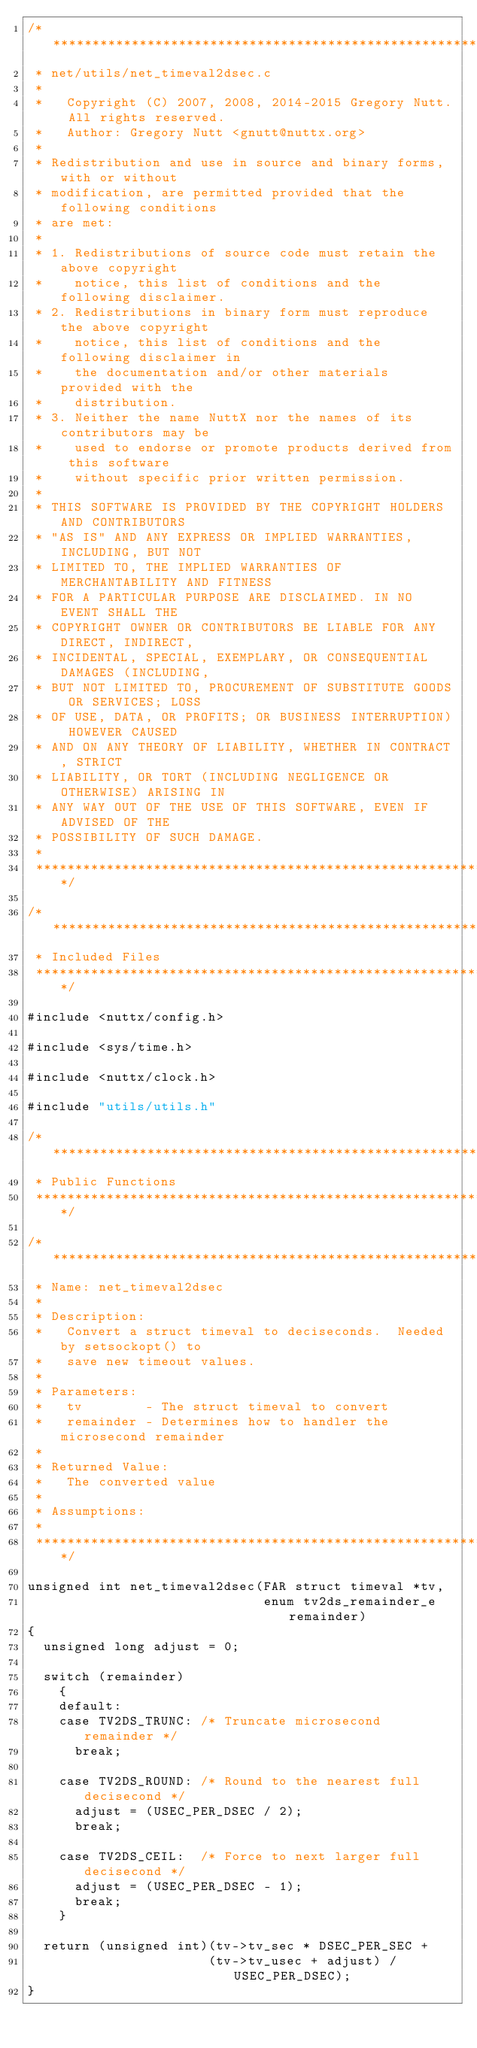<code> <loc_0><loc_0><loc_500><loc_500><_C_>/****************************************************************************
 * net/utils/net_timeval2dsec.c
 *
 *   Copyright (C) 2007, 2008, 2014-2015 Gregory Nutt. All rights reserved.
 *   Author: Gregory Nutt <gnutt@nuttx.org>
 *
 * Redistribution and use in source and binary forms, with or without
 * modification, are permitted provided that the following conditions
 * are met:
 *
 * 1. Redistributions of source code must retain the above copyright
 *    notice, this list of conditions and the following disclaimer.
 * 2. Redistributions in binary form must reproduce the above copyright
 *    notice, this list of conditions and the following disclaimer in
 *    the documentation and/or other materials provided with the
 *    distribution.
 * 3. Neither the name NuttX nor the names of its contributors may be
 *    used to endorse or promote products derived from this software
 *    without specific prior written permission.
 *
 * THIS SOFTWARE IS PROVIDED BY THE COPYRIGHT HOLDERS AND CONTRIBUTORS
 * "AS IS" AND ANY EXPRESS OR IMPLIED WARRANTIES, INCLUDING, BUT NOT
 * LIMITED TO, THE IMPLIED WARRANTIES OF MERCHANTABILITY AND FITNESS
 * FOR A PARTICULAR PURPOSE ARE DISCLAIMED. IN NO EVENT SHALL THE
 * COPYRIGHT OWNER OR CONTRIBUTORS BE LIABLE FOR ANY DIRECT, INDIRECT,
 * INCIDENTAL, SPECIAL, EXEMPLARY, OR CONSEQUENTIAL DAMAGES (INCLUDING,
 * BUT NOT LIMITED TO, PROCUREMENT OF SUBSTITUTE GOODS OR SERVICES; LOSS
 * OF USE, DATA, OR PROFITS; OR BUSINESS INTERRUPTION) HOWEVER CAUSED
 * AND ON ANY THEORY OF LIABILITY, WHETHER IN CONTRACT, STRICT
 * LIABILITY, OR TORT (INCLUDING NEGLIGENCE OR OTHERWISE) ARISING IN
 * ANY WAY OUT OF THE USE OF THIS SOFTWARE, EVEN IF ADVISED OF THE
 * POSSIBILITY OF SUCH DAMAGE.
 *
 ****************************************************************************/

/****************************************************************************
 * Included Files
 ****************************************************************************/

#include <nuttx/config.h>

#include <sys/time.h>

#include <nuttx/clock.h>

#include "utils/utils.h"

/****************************************************************************
 * Public Functions
 ****************************************************************************/

/****************************************************************************
 * Name: net_timeval2dsec
 *
 * Description:
 *   Convert a struct timeval to deciseconds.  Needed by setsockopt() to
 *   save new timeout values.
 *
 * Parameters:
 *   tv        - The struct timeval to convert
 *   remainder - Determines how to handler the microsecond remainder
 *
 * Returned Value:
 *   The converted value
 *
 * Assumptions:
 *
 ****************************************************************************/

unsigned int net_timeval2dsec(FAR struct timeval *tv,
                              enum tv2ds_remainder_e remainder)
{
  unsigned long adjust = 0;

  switch (remainder)
    {
    default:
    case TV2DS_TRUNC: /* Truncate microsecond remainder */
      break;

    case TV2DS_ROUND: /* Round to the nearest full decisecond */
      adjust = (USEC_PER_DSEC / 2);
      break;

    case TV2DS_CEIL:  /* Force to next larger full decisecond */
      adjust = (USEC_PER_DSEC - 1);
      break;
    }

  return (unsigned int)(tv->tv_sec * DSEC_PER_SEC +
                       (tv->tv_usec + adjust) / USEC_PER_DSEC);
}
</code> 